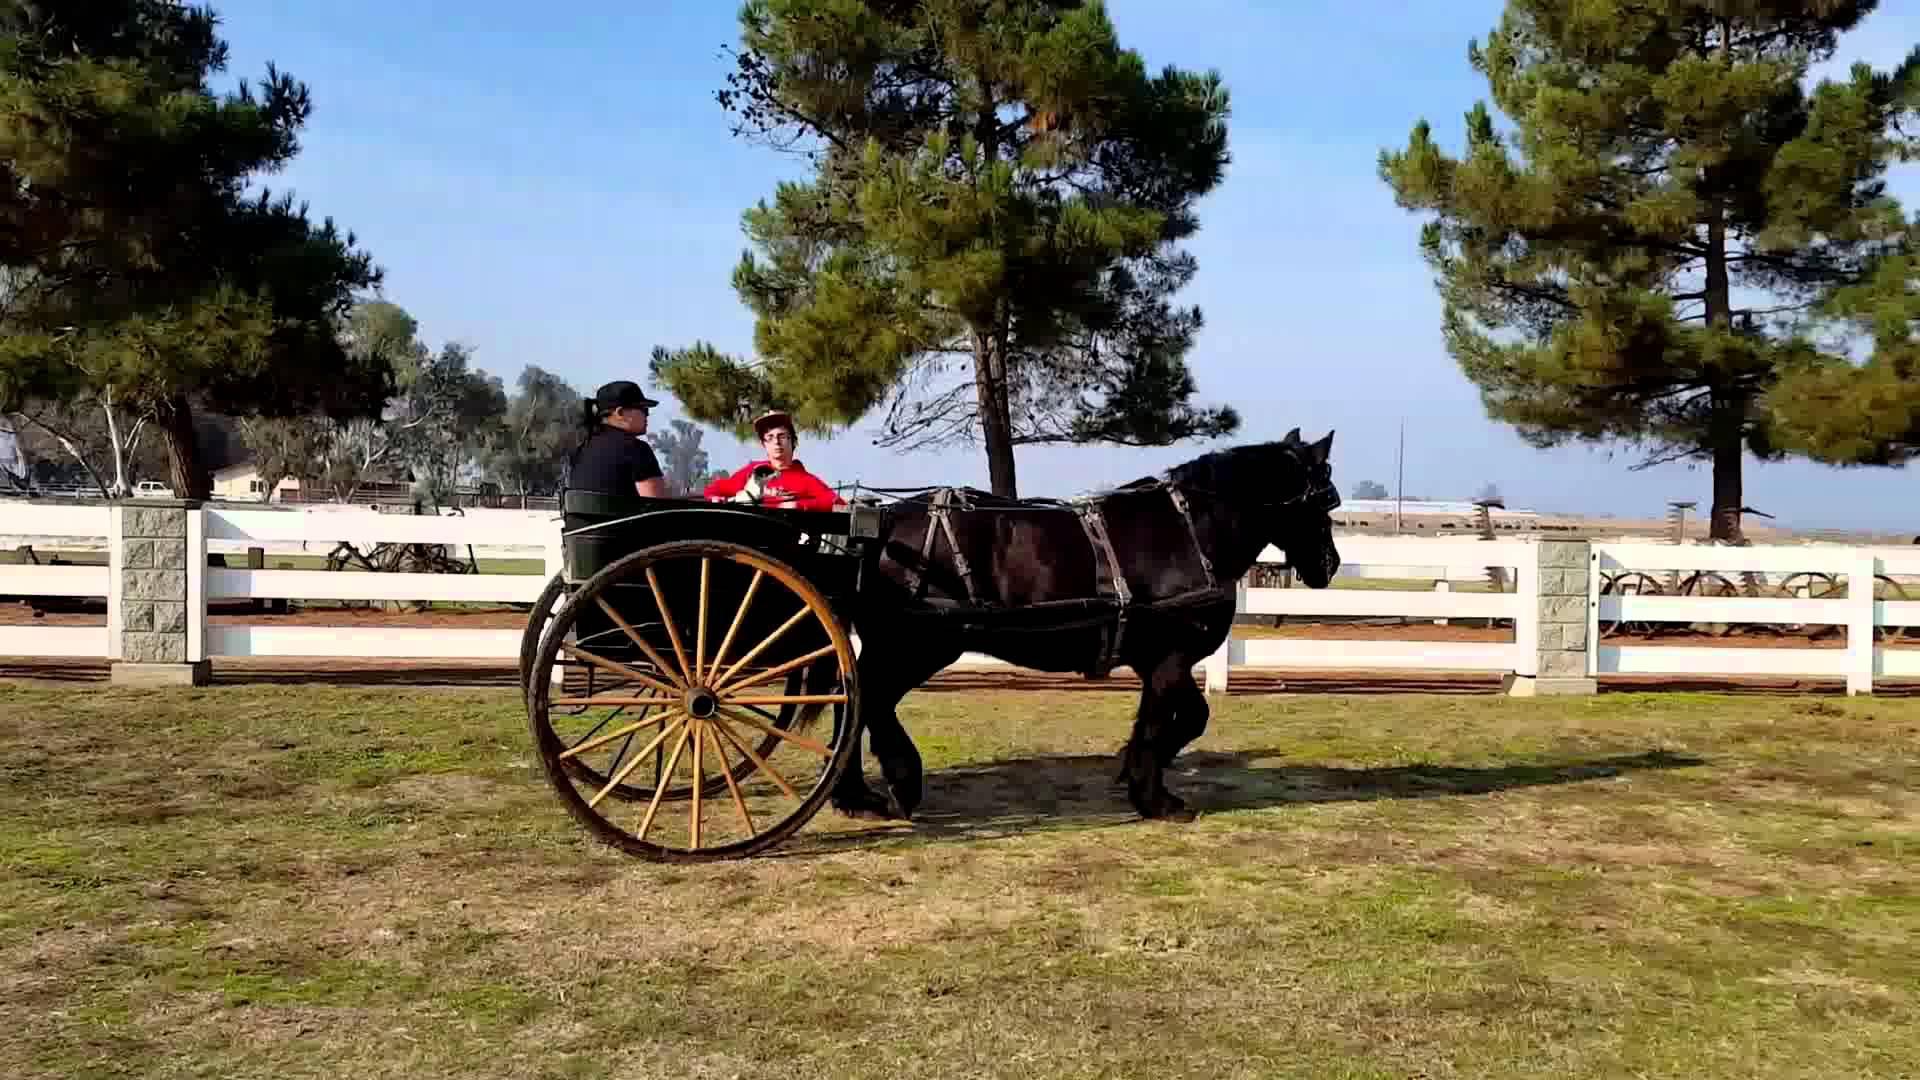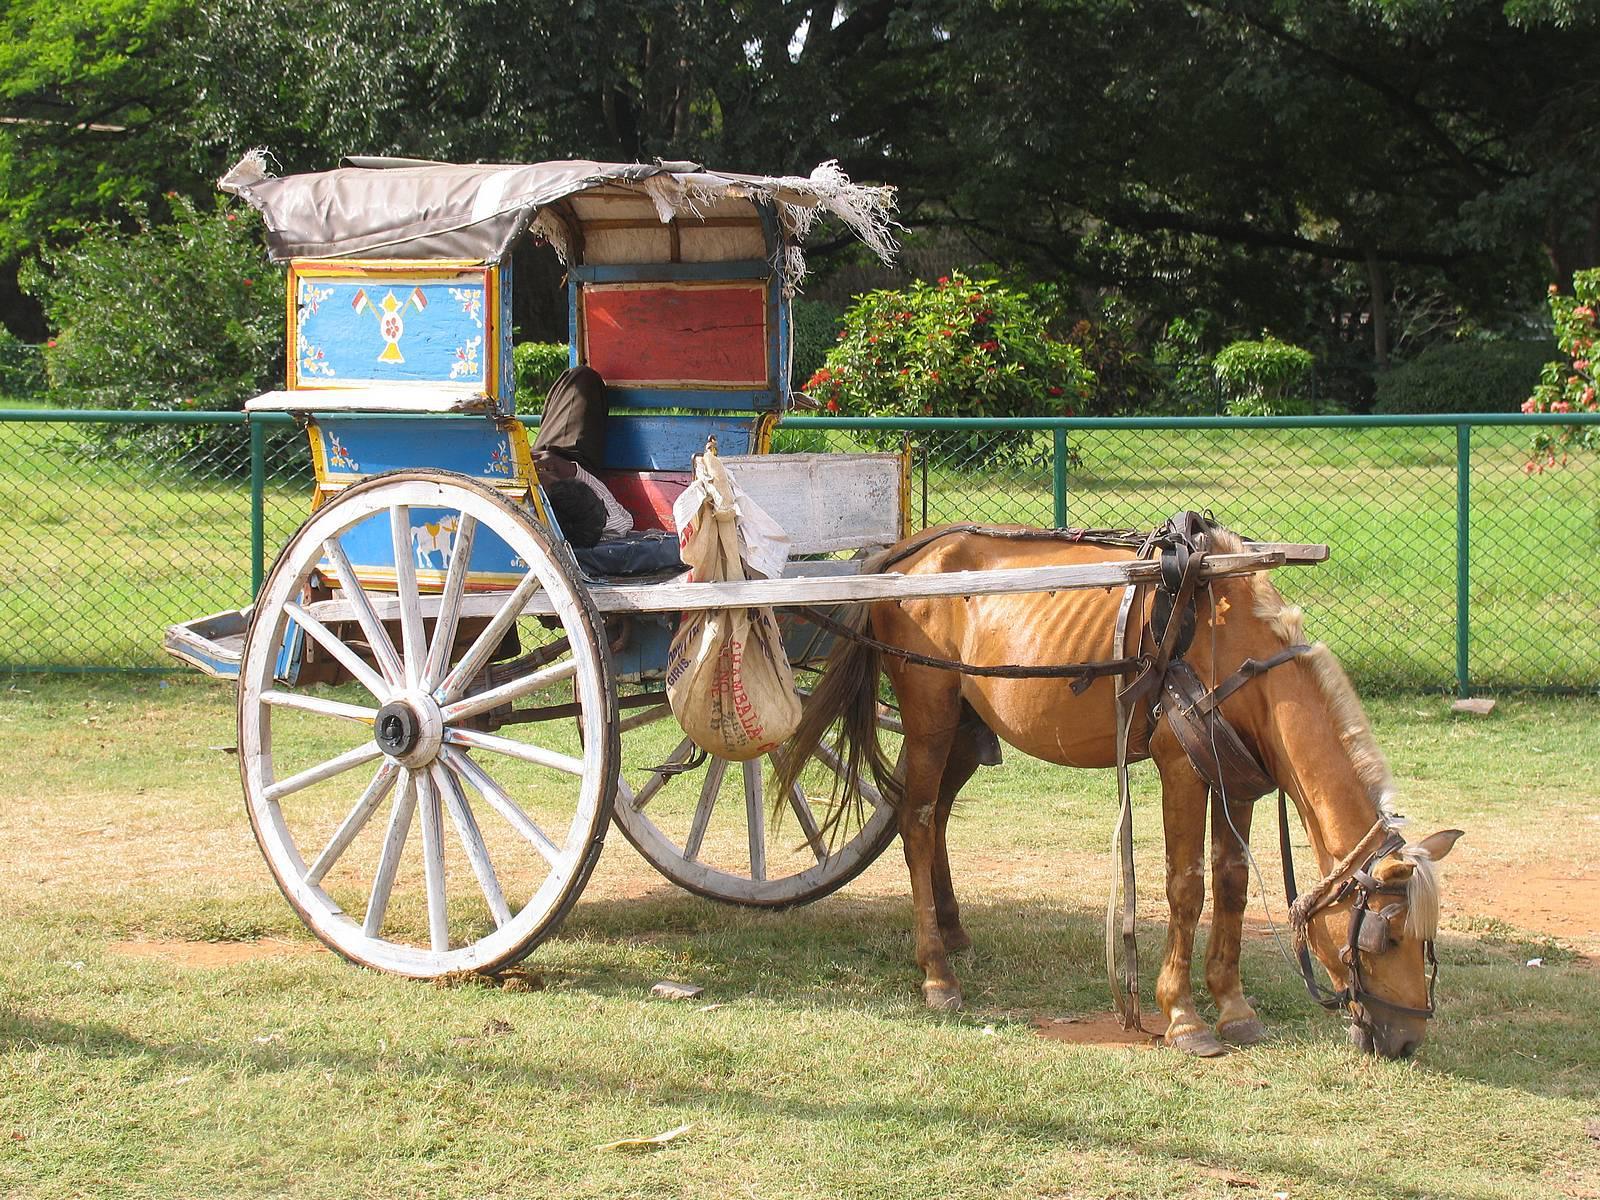The first image is the image on the left, the second image is the image on the right. Examine the images to the left and right. Is the description "All images show one full-size horse pulling a cart." accurate? Answer yes or no. Yes. 